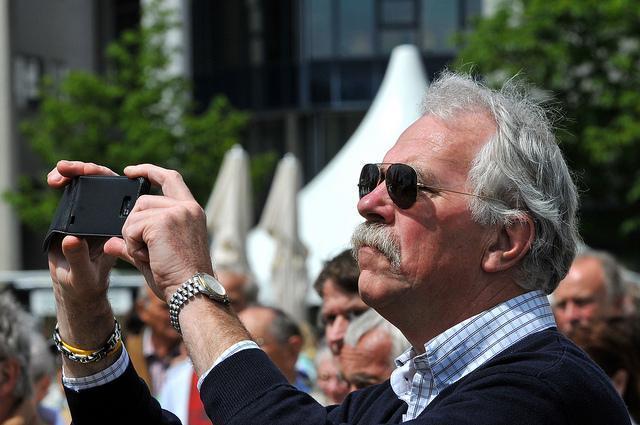How many people are there?
Give a very brief answer. 8. 